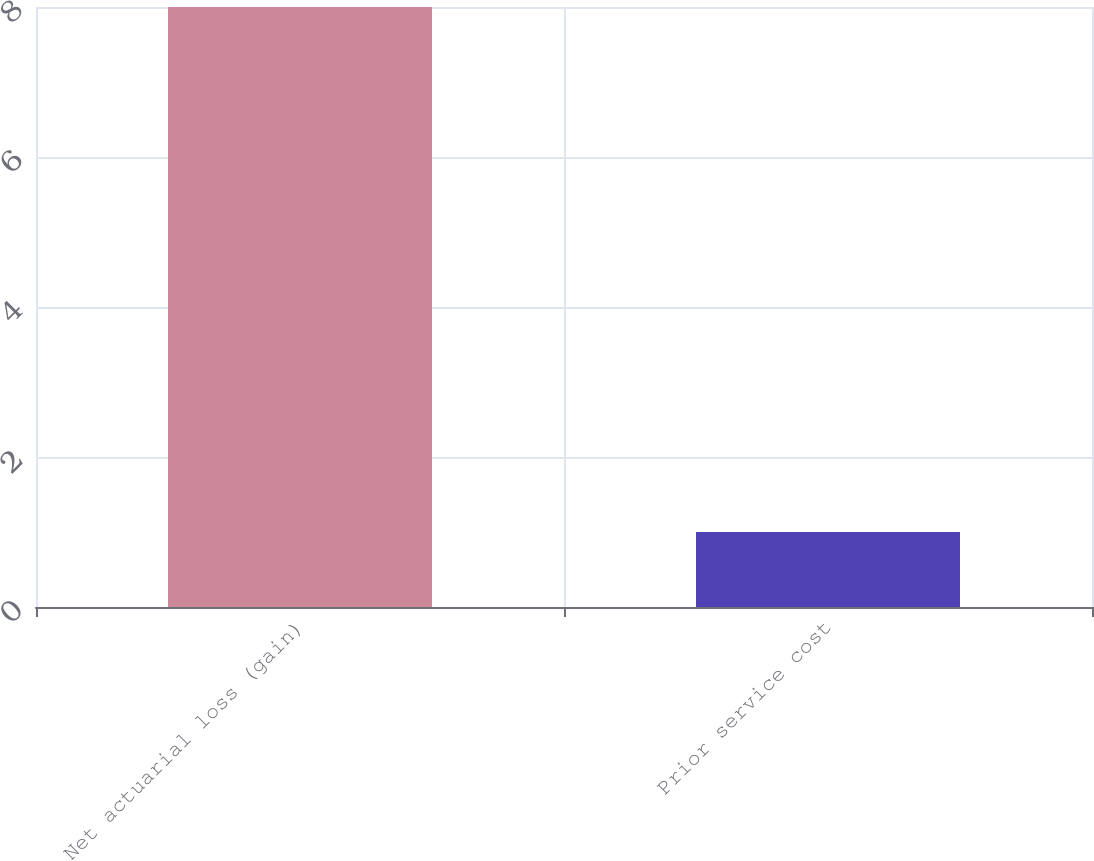Convert chart to OTSL. <chart><loc_0><loc_0><loc_500><loc_500><bar_chart><fcel>Net actuarial loss (gain)<fcel>Prior service cost<nl><fcel>8<fcel>1<nl></chart> 